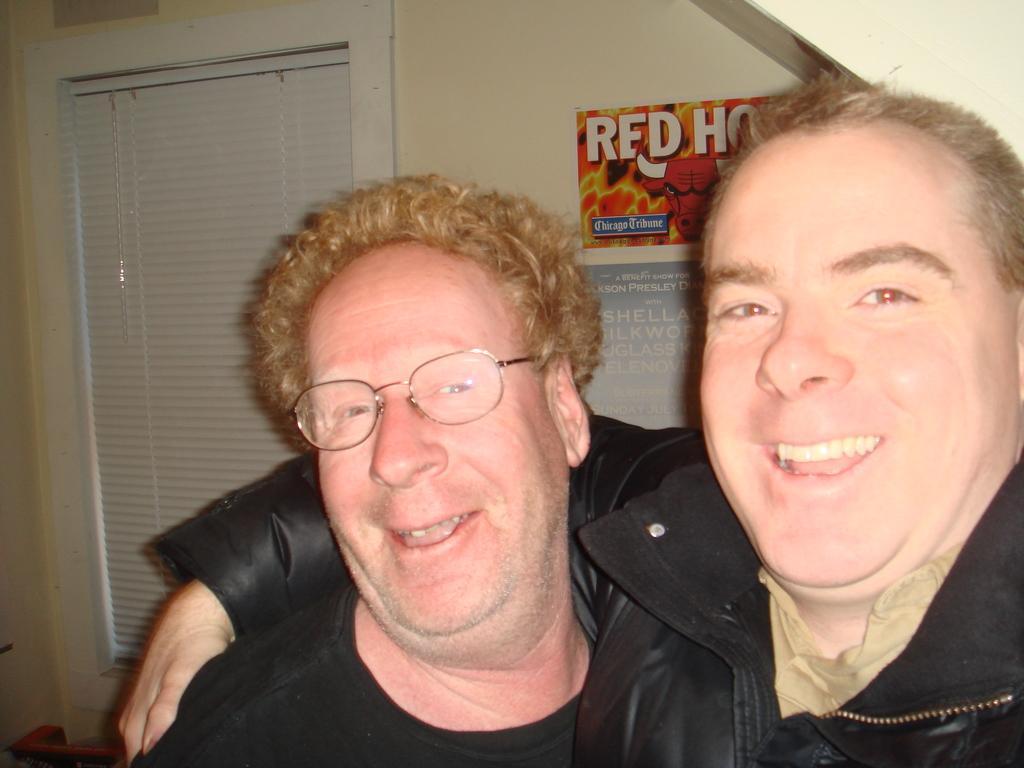In one or two sentences, can you explain what this image depicts? There are two men standing as we can see at the bottom of this image and there is a wall in the background. We can see a window on the left side of this image and a poster attached to the wall. 